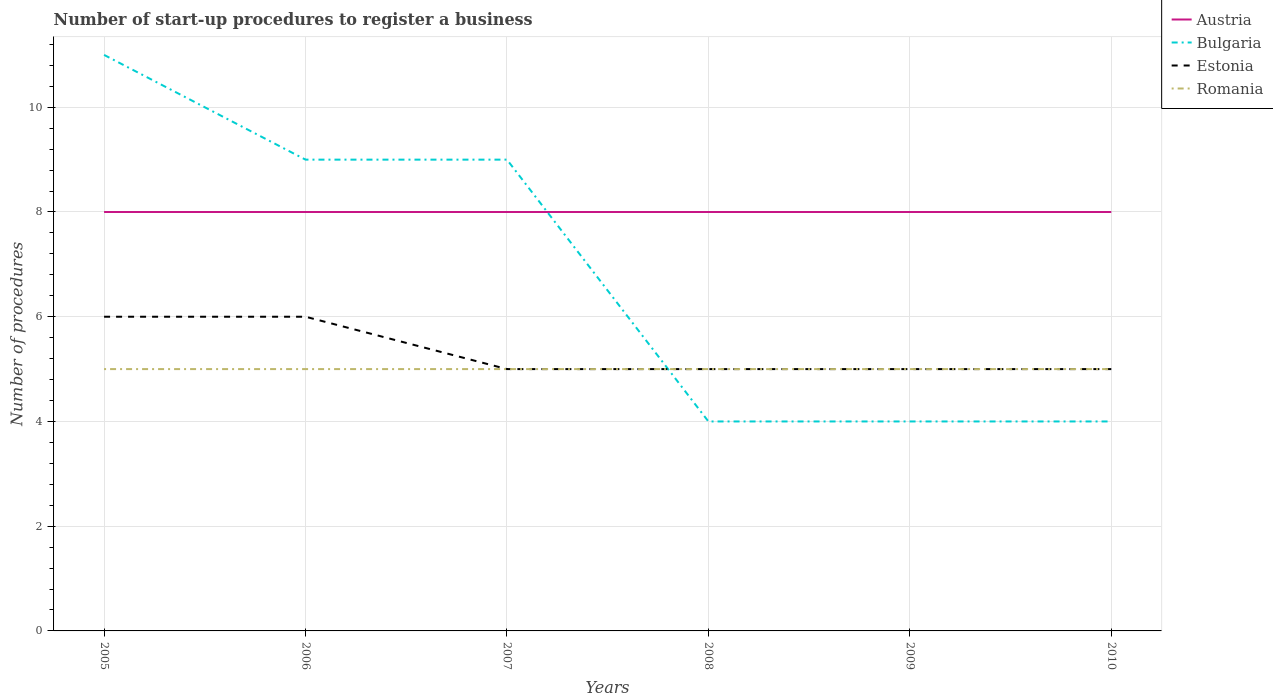Is the number of lines equal to the number of legend labels?
Offer a very short reply. Yes. Across all years, what is the maximum number of procedures required to register a business in Estonia?
Your answer should be very brief. 5. In which year was the number of procedures required to register a business in Austria maximum?
Offer a terse response. 2005. What is the total number of procedures required to register a business in Estonia in the graph?
Keep it short and to the point. 1. What is the difference between the highest and the second highest number of procedures required to register a business in Bulgaria?
Offer a very short reply. 7. Is the number of procedures required to register a business in Bulgaria strictly greater than the number of procedures required to register a business in Romania over the years?
Provide a succinct answer. No. How many lines are there?
Offer a terse response. 4. What is the difference between two consecutive major ticks on the Y-axis?
Make the answer very short. 2. Are the values on the major ticks of Y-axis written in scientific E-notation?
Provide a succinct answer. No. Does the graph contain any zero values?
Your response must be concise. No. Does the graph contain grids?
Offer a very short reply. Yes. How many legend labels are there?
Your answer should be very brief. 4. What is the title of the graph?
Offer a terse response. Number of start-up procedures to register a business. What is the label or title of the X-axis?
Provide a succinct answer. Years. What is the label or title of the Y-axis?
Provide a succinct answer. Number of procedures. What is the Number of procedures in Austria in 2005?
Keep it short and to the point. 8. What is the Number of procedures of Estonia in 2005?
Provide a succinct answer. 6. What is the Number of procedures of Romania in 2005?
Provide a succinct answer. 5. What is the Number of procedures of Austria in 2006?
Give a very brief answer. 8. What is the Number of procedures of Bulgaria in 2006?
Keep it short and to the point. 9. What is the Number of procedures of Estonia in 2006?
Your answer should be compact. 6. What is the Number of procedures of Romania in 2006?
Offer a terse response. 5. What is the Number of procedures of Bulgaria in 2007?
Keep it short and to the point. 9. What is the Number of procedures of Estonia in 2007?
Give a very brief answer. 5. What is the Number of procedures of Austria in 2008?
Your answer should be very brief. 8. What is the Number of procedures of Romania in 2009?
Your response must be concise. 5. What is the Number of procedures in Austria in 2010?
Your answer should be compact. 8. What is the Number of procedures of Bulgaria in 2010?
Provide a short and direct response. 4. What is the Number of procedures in Romania in 2010?
Your response must be concise. 5. Across all years, what is the maximum Number of procedures of Austria?
Give a very brief answer. 8. Across all years, what is the maximum Number of procedures of Bulgaria?
Ensure brevity in your answer.  11. Across all years, what is the maximum Number of procedures of Estonia?
Give a very brief answer. 6. Across all years, what is the minimum Number of procedures in Austria?
Offer a terse response. 8. Across all years, what is the minimum Number of procedures of Bulgaria?
Offer a terse response. 4. Across all years, what is the minimum Number of procedures in Estonia?
Offer a terse response. 5. Across all years, what is the minimum Number of procedures of Romania?
Your answer should be compact. 5. What is the total Number of procedures of Austria in the graph?
Keep it short and to the point. 48. What is the total Number of procedures of Bulgaria in the graph?
Offer a very short reply. 41. What is the total Number of procedures of Romania in the graph?
Keep it short and to the point. 30. What is the difference between the Number of procedures in Austria in 2005 and that in 2006?
Ensure brevity in your answer.  0. What is the difference between the Number of procedures in Estonia in 2005 and that in 2006?
Your answer should be compact. 0. What is the difference between the Number of procedures in Romania in 2005 and that in 2006?
Make the answer very short. 0. What is the difference between the Number of procedures of Estonia in 2005 and that in 2007?
Offer a terse response. 1. What is the difference between the Number of procedures in Estonia in 2005 and that in 2008?
Offer a terse response. 1. What is the difference between the Number of procedures in Romania in 2005 and that in 2008?
Offer a very short reply. 0. What is the difference between the Number of procedures in Austria in 2005 and that in 2010?
Your answer should be very brief. 0. What is the difference between the Number of procedures in Bulgaria in 2005 and that in 2010?
Your response must be concise. 7. What is the difference between the Number of procedures in Romania in 2005 and that in 2010?
Provide a succinct answer. 0. What is the difference between the Number of procedures of Austria in 2006 and that in 2007?
Ensure brevity in your answer.  0. What is the difference between the Number of procedures in Bulgaria in 2006 and that in 2007?
Your response must be concise. 0. What is the difference between the Number of procedures of Estonia in 2006 and that in 2007?
Offer a terse response. 1. What is the difference between the Number of procedures of Romania in 2006 and that in 2007?
Offer a terse response. 0. What is the difference between the Number of procedures in Bulgaria in 2006 and that in 2008?
Keep it short and to the point. 5. What is the difference between the Number of procedures in Estonia in 2006 and that in 2008?
Ensure brevity in your answer.  1. What is the difference between the Number of procedures in Romania in 2006 and that in 2008?
Your answer should be very brief. 0. What is the difference between the Number of procedures in Austria in 2006 and that in 2009?
Make the answer very short. 0. What is the difference between the Number of procedures in Bulgaria in 2006 and that in 2009?
Your answer should be very brief. 5. What is the difference between the Number of procedures in Estonia in 2006 and that in 2009?
Provide a succinct answer. 1. What is the difference between the Number of procedures of Romania in 2006 and that in 2009?
Your answer should be very brief. 0. What is the difference between the Number of procedures in Bulgaria in 2006 and that in 2010?
Your answer should be very brief. 5. What is the difference between the Number of procedures in Estonia in 2006 and that in 2010?
Make the answer very short. 1. What is the difference between the Number of procedures in Romania in 2006 and that in 2010?
Make the answer very short. 0. What is the difference between the Number of procedures in Austria in 2007 and that in 2008?
Provide a short and direct response. 0. What is the difference between the Number of procedures of Estonia in 2007 and that in 2008?
Ensure brevity in your answer.  0. What is the difference between the Number of procedures of Austria in 2007 and that in 2009?
Your answer should be compact. 0. What is the difference between the Number of procedures of Estonia in 2007 and that in 2009?
Make the answer very short. 0. What is the difference between the Number of procedures in Austria in 2007 and that in 2010?
Keep it short and to the point. 0. What is the difference between the Number of procedures in Bulgaria in 2007 and that in 2010?
Offer a terse response. 5. What is the difference between the Number of procedures of Estonia in 2007 and that in 2010?
Your response must be concise. 0. What is the difference between the Number of procedures in Austria in 2008 and that in 2009?
Ensure brevity in your answer.  0. What is the difference between the Number of procedures of Estonia in 2008 and that in 2009?
Your response must be concise. 0. What is the difference between the Number of procedures of Romania in 2008 and that in 2009?
Provide a short and direct response. 0. What is the difference between the Number of procedures in Austria in 2008 and that in 2010?
Offer a terse response. 0. What is the difference between the Number of procedures of Bulgaria in 2008 and that in 2010?
Provide a succinct answer. 0. What is the difference between the Number of procedures in Estonia in 2008 and that in 2010?
Your answer should be very brief. 0. What is the difference between the Number of procedures in Romania in 2008 and that in 2010?
Give a very brief answer. 0. What is the difference between the Number of procedures in Bulgaria in 2005 and the Number of procedures in Estonia in 2006?
Make the answer very short. 5. What is the difference between the Number of procedures of Bulgaria in 2005 and the Number of procedures of Romania in 2006?
Your answer should be very brief. 6. What is the difference between the Number of procedures of Austria in 2005 and the Number of procedures of Bulgaria in 2007?
Your answer should be very brief. -1. What is the difference between the Number of procedures of Bulgaria in 2005 and the Number of procedures of Romania in 2007?
Provide a short and direct response. 6. What is the difference between the Number of procedures in Estonia in 2005 and the Number of procedures in Romania in 2007?
Keep it short and to the point. 1. What is the difference between the Number of procedures of Austria in 2005 and the Number of procedures of Bulgaria in 2008?
Provide a short and direct response. 4. What is the difference between the Number of procedures in Austria in 2005 and the Number of procedures in Estonia in 2008?
Make the answer very short. 3. What is the difference between the Number of procedures of Bulgaria in 2005 and the Number of procedures of Romania in 2008?
Offer a very short reply. 6. What is the difference between the Number of procedures of Austria in 2005 and the Number of procedures of Estonia in 2009?
Ensure brevity in your answer.  3. What is the difference between the Number of procedures of Austria in 2005 and the Number of procedures of Romania in 2009?
Make the answer very short. 3. What is the difference between the Number of procedures in Bulgaria in 2005 and the Number of procedures in Estonia in 2009?
Provide a succinct answer. 6. What is the difference between the Number of procedures of Bulgaria in 2005 and the Number of procedures of Romania in 2009?
Provide a succinct answer. 6. What is the difference between the Number of procedures of Austria in 2005 and the Number of procedures of Bulgaria in 2010?
Keep it short and to the point. 4. What is the difference between the Number of procedures of Bulgaria in 2005 and the Number of procedures of Estonia in 2010?
Your answer should be very brief. 6. What is the difference between the Number of procedures of Estonia in 2005 and the Number of procedures of Romania in 2010?
Your response must be concise. 1. What is the difference between the Number of procedures in Austria in 2006 and the Number of procedures in Romania in 2007?
Provide a succinct answer. 3. What is the difference between the Number of procedures of Bulgaria in 2006 and the Number of procedures of Romania in 2007?
Your answer should be very brief. 4. What is the difference between the Number of procedures in Estonia in 2006 and the Number of procedures in Romania in 2007?
Your answer should be very brief. 1. What is the difference between the Number of procedures in Austria in 2006 and the Number of procedures in Bulgaria in 2008?
Keep it short and to the point. 4. What is the difference between the Number of procedures in Austria in 2006 and the Number of procedures in Estonia in 2008?
Offer a very short reply. 3. What is the difference between the Number of procedures of Austria in 2006 and the Number of procedures of Romania in 2008?
Ensure brevity in your answer.  3. What is the difference between the Number of procedures in Bulgaria in 2006 and the Number of procedures in Romania in 2008?
Keep it short and to the point. 4. What is the difference between the Number of procedures of Estonia in 2006 and the Number of procedures of Romania in 2008?
Give a very brief answer. 1. What is the difference between the Number of procedures in Austria in 2006 and the Number of procedures in Bulgaria in 2009?
Provide a succinct answer. 4. What is the difference between the Number of procedures of Austria in 2006 and the Number of procedures of Estonia in 2009?
Provide a short and direct response. 3. What is the difference between the Number of procedures in Bulgaria in 2006 and the Number of procedures in Romania in 2009?
Keep it short and to the point. 4. What is the difference between the Number of procedures of Estonia in 2006 and the Number of procedures of Romania in 2009?
Keep it short and to the point. 1. What is the difference between the Number of procedures in Bulgaria in 2006 and the Number of procedures in Estonia in 2010?
Offer a very short reply. 4. What is the difference between the Number of procedures of Bulgaria in 2006 and the Number of procedures of Romania in 2010?
Your response must be concise. 4. What is the difference between the Number of procedures in Austria in 2007 and the Number of procedures in Bulgaria in 2008?
Your response must be concise. 4. What is the difference between the Number of procedures of Austria in 2007 and the Number of procedures of Estonia in 2008?
Your response must be concise. 3. What is the difference between the Number of procedures of Bulgaria in 2007 and the Number of procedures of Romania in 2008?
Your answer should be compact. 4. What is the difference between the Number of procedures of Estonia in 2007 and the Number of procedures of Romania in 2008?
Ensure brevity in your answer.  0. What is the difference between the Number of procedures in Austria in 2007 and the Number of procedures in Bulgaria in 2009?
Ensure brevity in your answer.  4. What is the difference between the Number of procedures of Austria in 2007 and the Number of procedures of Romania in 2009?
Your answer should be very brief. 3. What is the difference between the Number of procedures of Estonia in 2007 and the Number of procedures of Romania in 2009?
Offer a very short reply. 0. What is the difference between the Number of procedures of Austria in 2007 and the Number of procedures of Estonia in 2010?
Your answer should be very brief. 3. What is the difference between the Number of procedures of Austria in 2007 and the Number of procedures of Romania in 2010?
Offer a terse response. 3. What is the difference between the Number of procedures in Estonia in 2007 and the Number of procedures in Romania in 2010?
Your answer should be very brief. 0. What is the difference between the Number of procedures in Austria in 2008 and the Number of procedures in Estonia in 2009?
Provide a short and direct response. 3. What is the difference between the Number of procedures of Austria in 2008 and the Number of procedures of Romania in 2009?
Provide a short and direct response. 3. What is the difference between the Number of procedures in Estonia in 2008 and the Number of procedures in Romania in 2009?
Give a very brief answer. 0. What is the difference between the Number of procedures in Austria in 2008 and the Number of procedures in Estonia in 2010?
Provide a succinct answer. 3. What is the difference between the Number of procedures of Austria in 2008 and the Number of procedures of Romania in 2010?
Provide a succinct answer. 3. What is the difference between the Number of procedures in Bulgaria in 2008 and the Number of procedures in Estonia in 2010?
Offer a terse response. -1. What is the difference between the Number of procedures in Austria in 2009 and the Number of procedures in Estonia in 2010?
Offer a very short reply. 3. What is the average Number of procedures in Austria per year?
Your response must be concise. 8. What is the average Number of procedures in Bulgaria per year?
Your answer should be compact. 6.83. What is the average Number of procedures of Estonia per year?
Your response must be concise. 5.33. In the year 2005, what is the difference between the Number of procedures in Bulgaria and Number of procedures in Romania?
Ensure brevity in your answer.  6. In the year 2005, what is the difference between the Number of procedures in Estonia and Number of procedures in Romania?
Offer a terse response. 1. In the year 2006, what is the difference between the Number of procedures of Austria and Number of procedures of Bulgaria?
Offer a terse response. -1. In the year 2006, what is the difference between the Number of procedures of Bulgaria and Number of procedures of Romania?
Give a very brief answer. 4. In the year 2007, what is the difference between the Number of procedures of Austria and Number of procedures of Bulgaria?
Offer a terse response. -1. In the year 2007, what is the difference between the Number of procedures in Austria and Number of procedures in Estonia?
Make the answer very short. 3. In the year 2008, what is the difference between the Number of procedures in Austria and Number of procedures in Bulgaria?
Your answer should be compact. 4. In the year 2008, what is the difference between the Number of procedures in Austria and Number of procedures in Estonia?
Provide a short and direct response. 3. In the year 2009, what is the difference between the Number of procedures in Austria and Number of procedures in Bulgaria?
Keep it short and to the point. 4. In the year 2009, what is the difference between the Number of procedures in Austria and Number of procedures in Estonia?
Your answer should be very brief. 3. In the year 2009, what is the difference between the Number of procedures of Bulgaria and Number of procedures of Romania?
Keep it short and to the point. -1. In the year 2009, what is the difference between the Number of procedures in Estonia and Number of procedures in Romania?
Provide a succinct answer. 0. In the year 2010, what is the difference between the Number of procedures in Austria and Number of procedures in Bulgaria?
Give a very brief answer. 4. In the year 2010, what is the difference between the Number of procedures in Austria and Number of procedures in Romania?
Your answer should be very brief. 3. In the year 2010, what is the difference between the Number of procedures in Bulgaria and Number of procedures in Estonia?
Make the answer very short. -1. In the year 2010, what is the difference between the Number of procedures in Bulgaria and Number of procedures in Romania?
Offer a very short reply. -1. What is the ratio of the Number of procedures in Bulgaria in 2005 to that in 2006?
Provide a succinct answer. 1.22. What is the ratio of the Number of procedures in Austria in 2005 to that in 2007?
Offer a terse response. 1. What is the ratio of the Number of procedures of Bulgaria in 2005 to that in 2007?
Keep it short and to the point. 1.22. What is the ratio of the Number of procedures in Bulgaria in 2005 to that in 2008?
Make the answer very short. 2.75. What is the ratio of the Number of procedures of Romania in 2005 to that in 2008?
Keep it short and to the point. 1. What is the ratio of the Number of procedures in Austria in 2005 to that in 2009?
Offer a terse response. 1. What is the ratio of the Number of procedures in Bulgaria in 2005 to that in 2009?
Make the answer very short. 2.75. What is the ratio of the Number of procedures in Estonia in 2005 to that in 2009?
Make the answer very short. 1.2. What is the ratio of the Number of procedures of Romania in 2005 to that in 2009?
Your answer should be compact. 1. What is the ratio of the Number of procedures of Austria in 2005 to that in 2010?
Provide a short and direct response. 1. What is the ratio of the Number of procedures in Bulgaria in 2005 to that in 2010?
Make the answer very short. 2.75. What is the ratio of the Number of procedures of Estonia in 2005 to that in 2010?
Your answer should be very brief. 1.2. What is the ratio of the Number of procedures of Bulgaria in 2006 to that in 2007?
Your response must be concise. 1. What is the ratio of the Number of procedures of Estonia in 2006 to that in 2007?
Your answer should be very brief. 1.2. What is the ratio of the Number of procedures in Romania in 2006 to that in 2007?
Make the answer very short. 1. What is the ratio of the Number of procedures in Bulgaria in 2006 to that in 2008?
Give a very brief answer. 2.25. What is the ratio of the Number of procedures in Estonia in 2006 to that in 2008?
Your response must be concise. 1.2. What is the ratio of the Number of procedures in Romania in 2006 to that in 2008?
Offer a very short reply. 1. What is the ratio of the Number of procedures of Bulgaria in 2006 to that in 2009?
Offer a terse response. 2.25. What is the ratio of the Number of procedures of Estonia in 2006 to that in 2009?
Your response must be concise. 1.2. What is the ratio of the Number of procedures of Romania in 2006 to that in 2009?
Ensure brevity in your answer.  1. What is the ratio of the Number of procedures in Austria in 2006 to that in 2010?
Make the answer very short. 1. What is the ratio of the Number of procedures in Bulgaria in 2006 to that in 2010?
Offer a terse response. 2.25. What is the ratio of the Number of procedures of Romania in 2006 to that in 2010?
Ensure brevity in your answer.  1. What is the ratio of the Number of procedures of Bulgaria in 2007 to that in 2008?
Provide a succinct answer. 2.25. What is the ratio of the Number of procedures of Estonia in 2007 to that in 2008?
Give a very brief answer. 1. What is the ratio of the Number of procedures in Romania in 2007 to that in 2008?
Your answer should be compact. 1. What is the ratio of the Number of procedures of Bulgaria in 2007 to that in 2009?
Your answer should be very brief. 2.25. What is the ratio of the Number of procedures of Estonia in 2007 to that in 2009?
Provide a short and direct response. 1. What is the ratio of the Number of procedures in Austria in 2007 to that in 2010?
Offer a very short reply. 1. What is the ratio of the Number of procedures in Bulgaria in 2007 to that in 2010?
Your response must be concise. 2.25. What is the ratio of the Number of procedures in Estonia in 2007 to that in 2010?
Offer a very short reply. 1. What is the ratio of the Number of procedures of Romania in 2007 to that in 2010?
Keep it short and to the point. 1. What is the ratio of the Number of procedures in Estonia in 2008 to that in 2009?
Offer a terse response. 1. What is the ratio of the Number of procedures in Romania in 2008 to that in 2009?
Your answer should be compact. 1. What is the ratio of the Number of procedures of Austria in 2008 to that in 2010?
Your answer should be compact. 1. What is the ratio of the Number of procedures of Bulgaria in 2008 to that in 2010?
Your response must be concise. 1. What is the ratio of the Number of procedures in Romania in 2008 to that in 2010?
Your response must be concise. 1. What is the ratio of the Number of procedures in Romania in 2009 to that in 2010?
Offer a very short reply. 1. What is the difference between the highest and the second highest Number of procedures of Austria?
Ensure brevity in your answer.  0. What is the difference between the highest and the second highest Number of procedures of Estonia?
Offer a terse response. 0. What is the difference between the highest and the second highest Number of procedures in Romania?
Ensure brevity in your answer.  0. What is the difference between the highest and the lowest Number of procedures of Austria?
Ensure brevity in your answer.  0. What is the difference between the highest and the lowest Number of procedures in Bulgaria?
Provide a short and direct response. 7. What is the difference between the highest and the lowest Number of procedures of Estonia?
Keep it short and to the point. 1. 